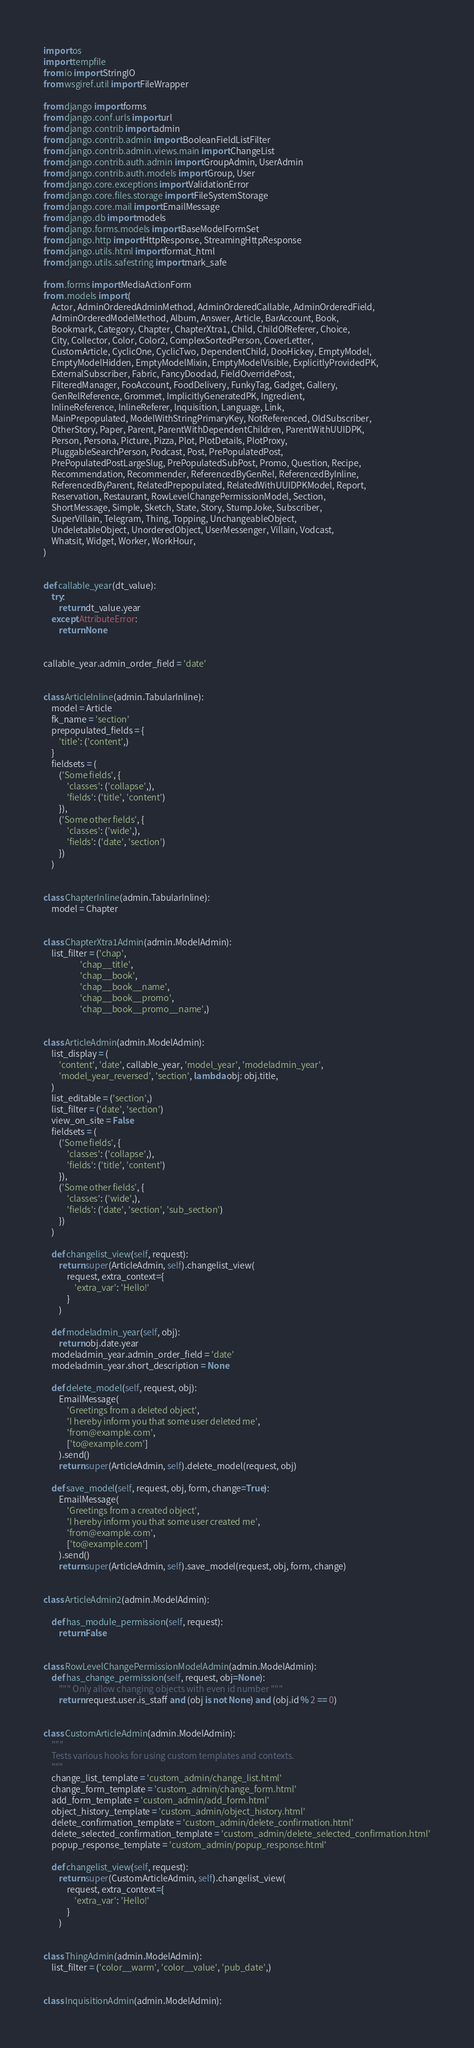<code> <loc_0><loc_0><loc_500><loc_500><_Python_>import os
import tempfile
from io import StringIO
from wsgiref.util import FileWrapper

from django import forms
from django.conf.urls import url
from django.contrib import admin
from django.contrib.admin import BooleanFieldListFilter
from django.contrib.admin.views.main import ChangeList
from django.contrib.auth.admin import GroupAdmin, UserAdmin
from django.contrib.auth.models import Group, User
from django.core.exceptions import ValidationError
from django.core.files.storage import FileSystemStorage
from django.core.mail import EmailMessage
from django.db import models
from django.forms.models import BaseModelFormSet
from django.http import HttpResponse, StreamingHttpResponse
from django.utils.html import format_html
from django.utils.safestring import mark_safe

from .forms import MediaActionForm
from .models import (
    Actor, AdminOrderedAdminMethod, AdminOrderedCallable, AdminOrderedField,
    AdminOrderedModelMethod, Album, Answer, Article, BarAccount, Book,
    Bookmark, Category, Chapter, ChapterXtra1, Child, ChildOfReferer, Choice,
    City, Collector, Color, Color2, ComplexSortedPerson, CoverLetter,
    CustomArticle, CyclicOne, CyclicTwo, DependentChild, DooHickey, EmptyModel,
    EmptyModelHidden, EmptyModelMixin, EmptyModelVisible, ExplicitlyProvidedPK,
    ExternalSubscriber, Fabric, FancyDoodad, FieldOverridePost,
    FilteredManager, FooAccount, FoodDelivery, FunkyTag, Gadget, Gallery,
    GenRelReference, Grommet, ImplicitlyGeneratedPK, Ingredient,
    InlineReference, InlineReferer, Inquisition, Language, Link,
    MainPrepopulated, ModelWithStringPrimaryKey, NotReferenced, OldSubscriber,
    OtherStory, Paper, Parent, ParentWithDependentChildren, ParentWithUUIDPK,
    Person, Persona, Picture, Pizza, Plot, PlotDetails, PlotProxy,
    PluggableSearchPerson, Podcast, Post, PrePopulatedPost,
    PrePopulatedPostLargeSlug, PrePopulatedSubPost, Promo, Question, Recipe,
    Recommendation, Recommender, ReferencedByGenRel, ReferencedByInline,
    ReferencedByParent, RelatedPrepopulated, RelatedWithUUIDPKModel, Report,
    Reservation, Restaurant, RowLevelChangePermissionModel, Section,
    ShortMessage, Simple, Sketch, State, Story, StumpJoke, Subscriber,
    SuperVillain, Telegram, Thing, Topping, UnchangeableObject,
    UndeletableObject, UnorderedObject, UserMessenger, Villain, Vodcast,
    Whatsit, Widget, Worker, WorkHour,
)


def callable_year(dt_value):
    try:
        return dt_value.year
    except AttributeError:
        return None


callable_year.admin_order_field = 'date'


class ArticleInline(admin.TabularInline):
    model = Article
    fk_name = 'section'
    prepopulated_fields = {
        'title': ('content',)
    }
    fieldsets = (
        ('Some fields', {
            'classes': ('collapse',),
            'fields': ('title', 'content')
        }),
        ('Some other fields', {
            'classes': ('wide',),
            'fields': ('date', 'section')
        })
    )


class ChapterInline(admin.TabularInline):
    model = Chapter


class ChapterXtra1Admin(admin.ModelAdmin):
    list_filter = ('chap',
                   'chap__title',
                   'chap__book',
                   'chap__book__name',
                   'chap__book__promo',
                   'chap__book__promo__name',)


class ArticleAdmin(admin.ModelAdmin):
    list_display = (
        'content', 'date', callable_year, 'model_year', 'modeladmin_year',
        'model_year_reversed', 'section', lambda obj: obj.title,
    )
    list_editable = ('section',)
    list_filter = ('date', 'section')
    view_on_site = False
    fieldsets = (
        ('Some fields', {
            'classes': ('collapse',),
            'fields': ('title', 'content')
        }),
        ('Some other fields', {
            'classes': ('wide',),
            'fields': ('date', 'section', 'sub_section')
        })
    )

    def changelist_view(self, request):
        return super(ArticleAdmin, self).changelist_view(
            request, extra_context={
                'extra_var': 'Hello!'
            }
        )

    def modeladmin_year(self, obj):
        return obj.date.year
    modeladmin_year.admin_order_field = 'date'
    modeladmin_year.short_description = None

    def delete_model(self, request, obj):
        EmailMessage(
            'Greetings from a deleted object',
            'I hereby inform you that some user deleted me',
            'from@example.com',
            ['to@example.com']
        ).send()
        return super(ArticleAdmin, self).delete_model(request, obj)

    def save_model(self, request, obj, form, change=True):
        EmailMessage(
            'Greetings from a created object',
            'I hereby inform you that some user created me',
            'from@example.com',
            ['to@example.com']
        ).send()
        return super(ArticleAdmin, self).save_model(request, obj, form, change)


class ArticleAdmin2(admin.ModelAdmin):

    def has_module_permission(self, request):
        return False


class RowLevelChangePermissionModelAdmin(admin.ModelAdmin):
    def has_change_permission(self, request, obj=None):
        """ Only allow changing objects with even id number """
        return request.user.is_staff and (obj is not None) and (obj.id % 2 == 0)


class CustomArticleAdmin(admin.ModelAdmin):
    """
    Tests various hooks for using custom templates and contexts.
    """
    change_list_template = 'custom_admin/change_list.html'
    change_form_template = 'custom_admin/change_form.html'
    add_form_template = 'custom_admin/add_form.html'
    object_history_template = 'custom_admin/object_history.html'
    delete_confirmation_template = 'custom_admin/delete_confirmation.html'
    delete_selected_confirmation_template = 'custom_admin/delete_selected_confirmation.html'
    popup_response_template = 'custom_admin/popup_response.html'

    def changelist_view(self, request):
        return super(CustomArticleAdmin, self).changelist_view(
            request, extra_context={
                'extra_var': 'Hello!'
            }
        )


class ThingAdmin(admin.ModelAdmin):
    list_filter = ('color__warm', 'color__value', 'pub_date',)


class InquisitionAdmin(admin.ModelAdmin):</code> 